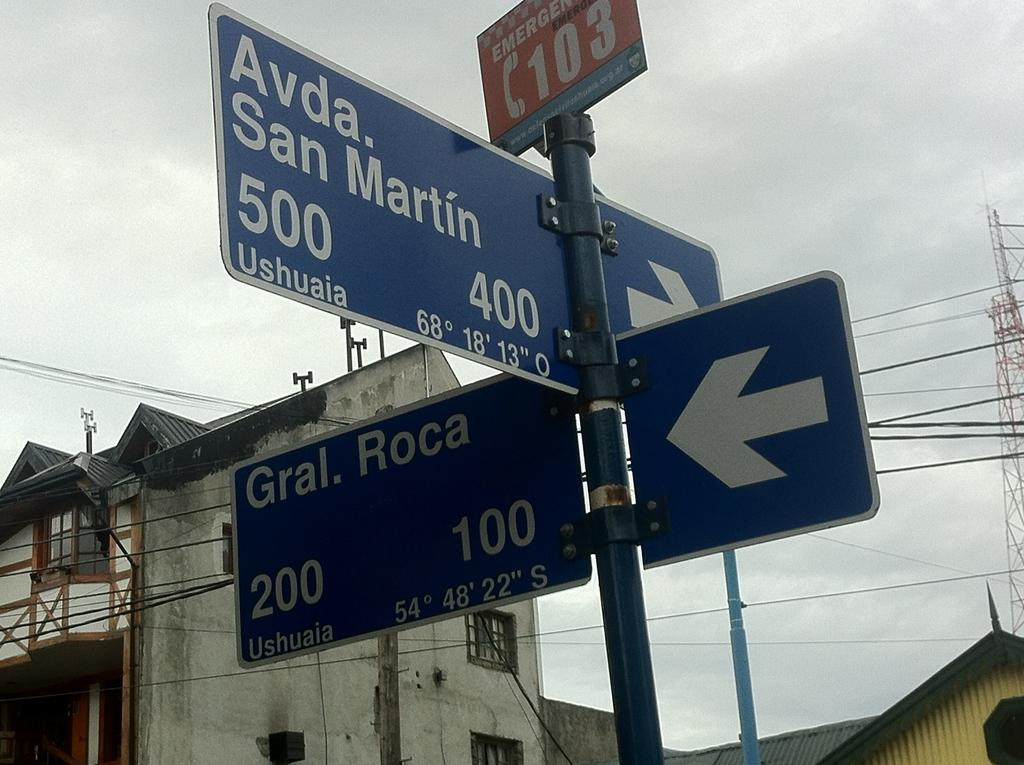<image>
Summarize the visual content of the image. a crosspost for Avada San Martin and Gral. Roca 